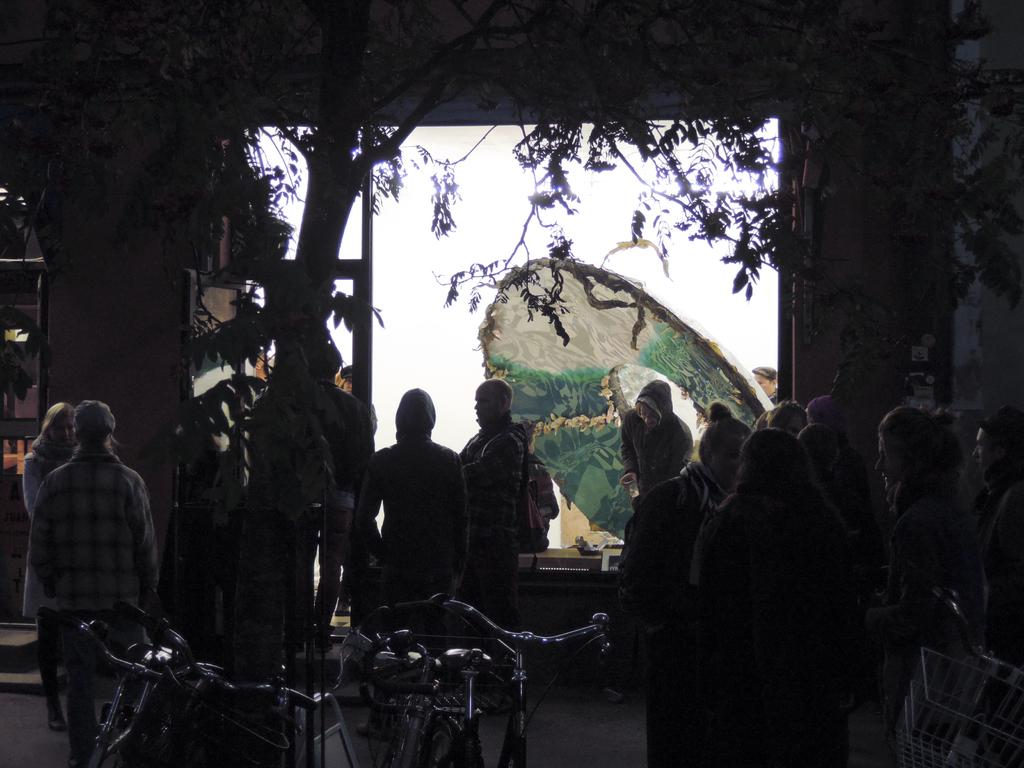What is the setting of the image? The group of men and women is standing inside a warehouse. What are the people in the image doing? The group is discussing something. What can be seen in the background of the image? There is a tree and a white and green color decorative umbrella visible in the background. What type of cord is being used to burst the soda can in the image? There is no cord or soda can present in the image. 